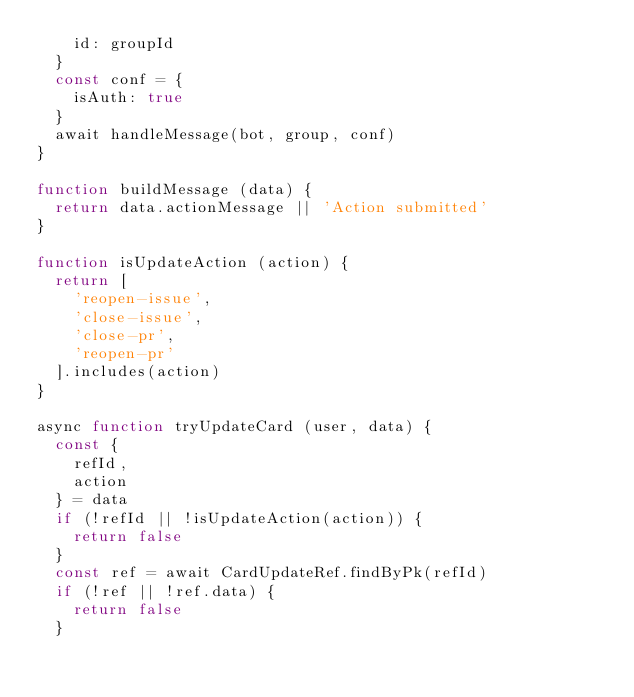Convert code to text. <code><loc_0><loc_0><loc_500><loc_500><_JavaScript_>    id: groupId
  }
  const conf = {
    isAuth: true
  }
  await handleMessage(bot, group, conf)
}

function buildMessage (data) {
  return data.actionMessage || 'Action submitted'
}

function isUpdateAction (action) {
  return [
    'reopen-issue',
    'close-issue',
    'close-pr',
    'reopen-pr'
  ].includes(action)
}

async function tryUpdateCard (user, data) {
  const {
    refId,
    action
  } = data
  if (!refId || !isUpdateAction(action)) {
    return false
  }
  const ref = await CardUpdateRef.findByPk(refId)
  if (!ref || !ref.data) {
    return false
  }</code> 